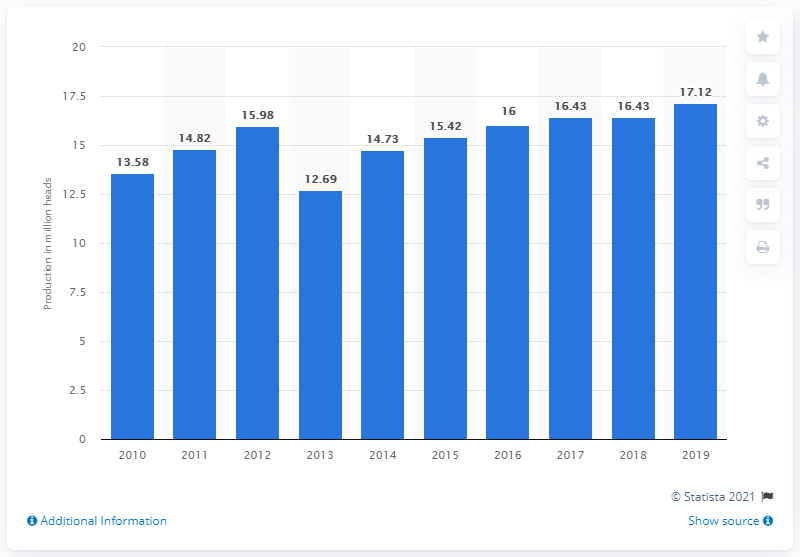Highlight a few significant elements in this photo. In 2019, a total of 17.12 million head of cattle were produced in Indonesia. 